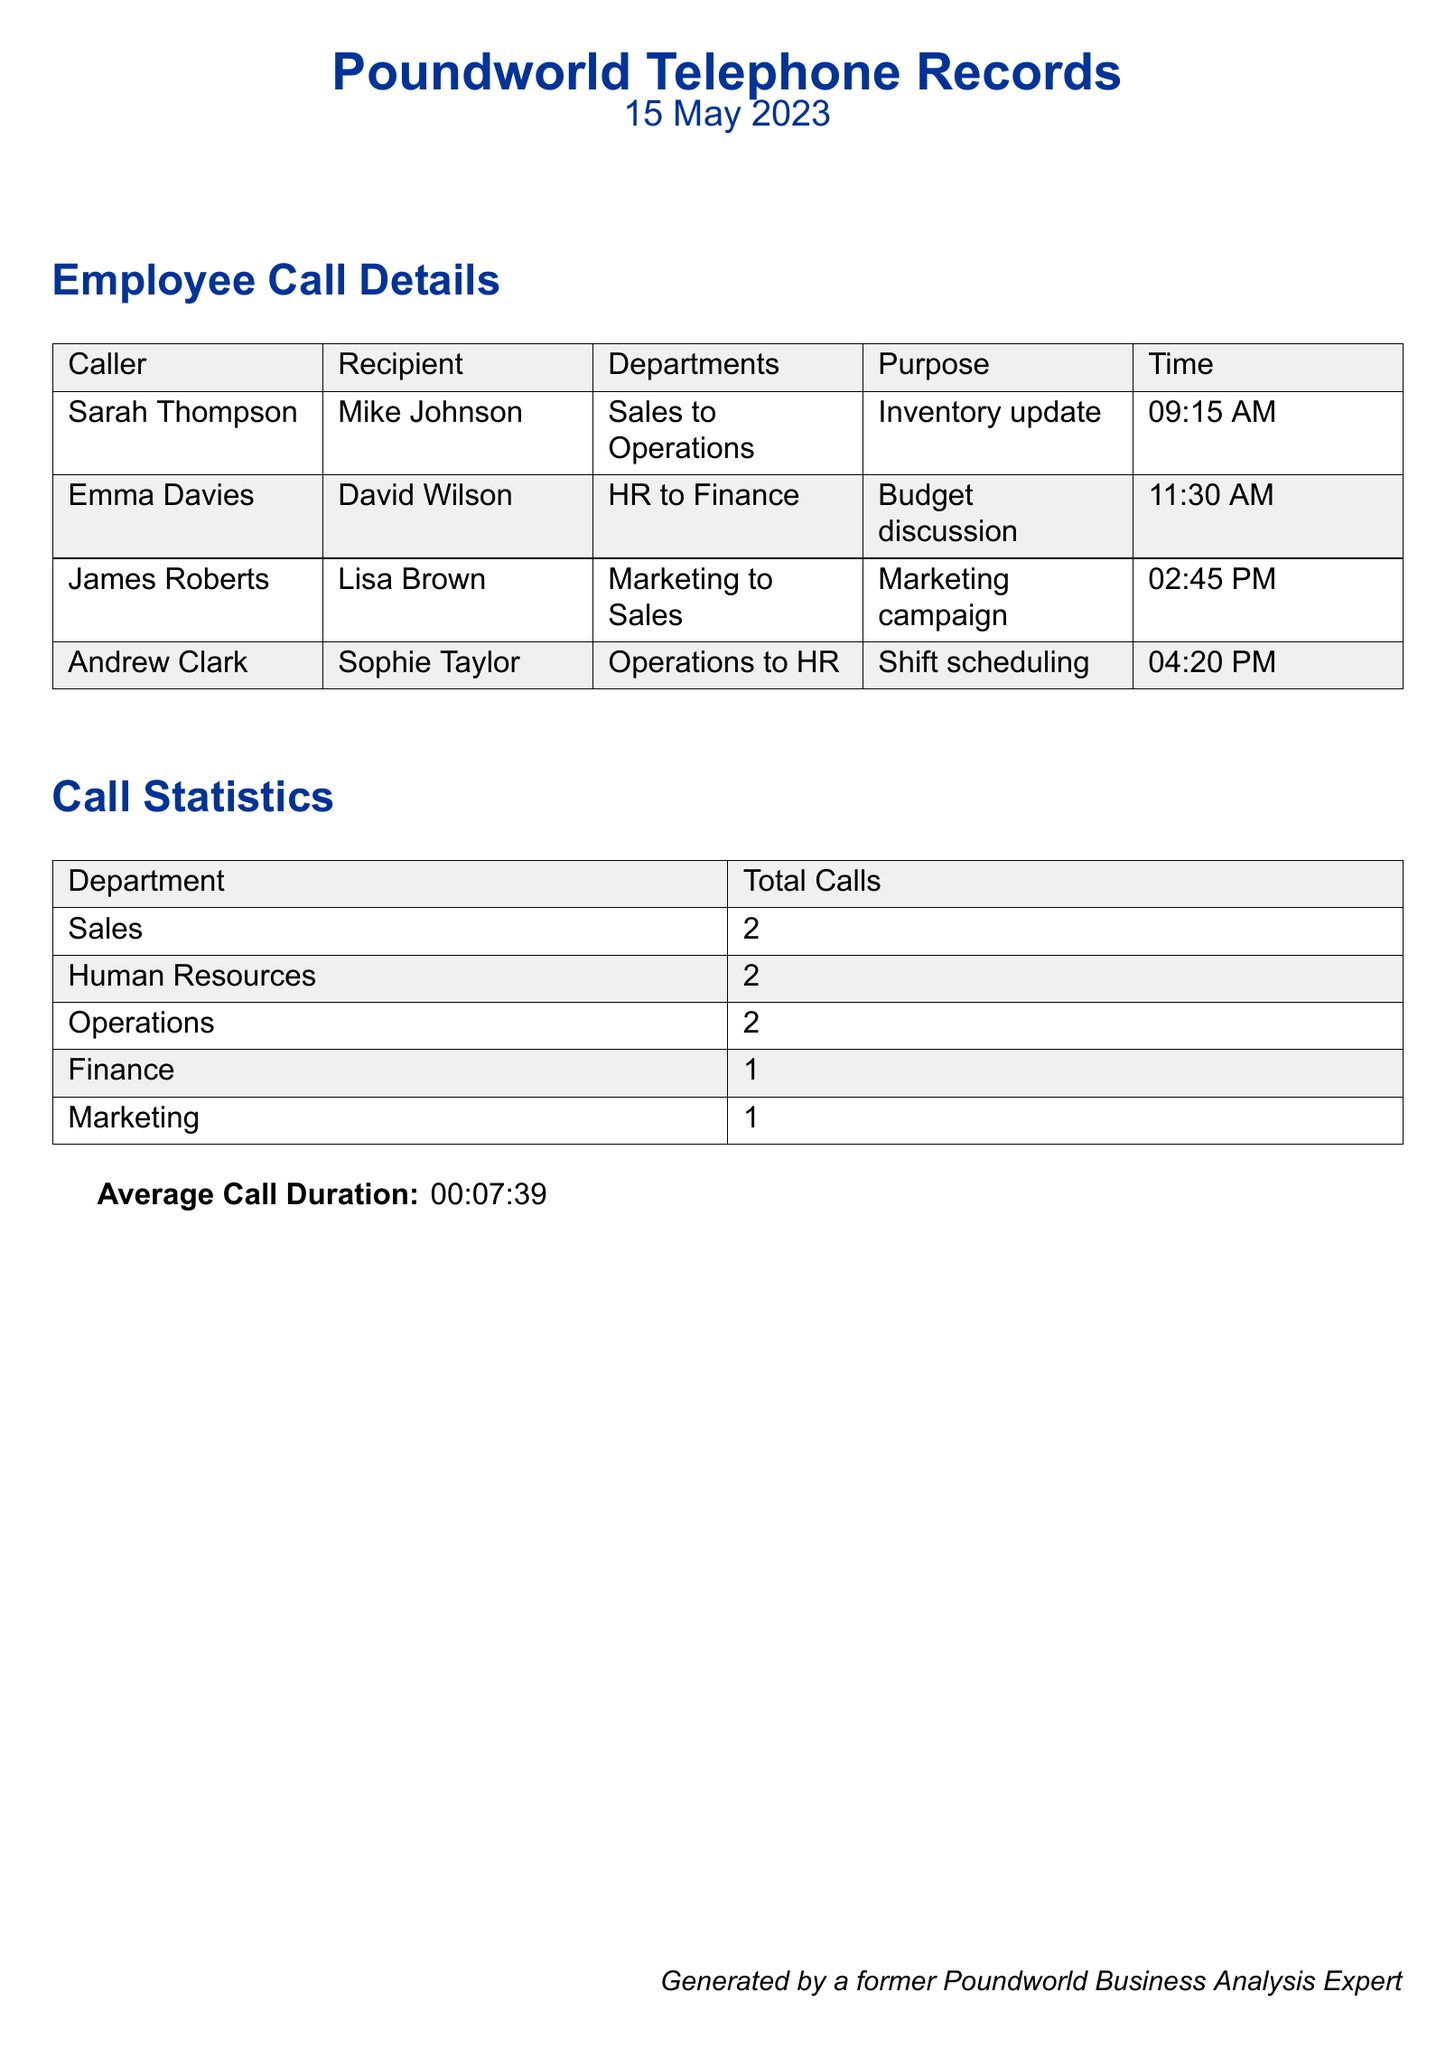What is the date of the telephone records? The date of the telephone records is mentioned at the top of the document as "15 May 2023."
Answer: 15 May 2023 Who called Mike Johnson? The caller who contacted Mike Johnson is identified as Sarah Thompson in the call details.
Answer: Sarah Thompson How many total calls were made by the Sales department? The total number of calls made by the Sales department is listed in the call statistics section as 2.
Answer: 2 What was the purpose of the call between Emma Davies and David Wilson? The purpose of the call is stated in the document as a "Budget discussion."
Answer: Budget discussion Which department made the fewest calls? By analyzing the call statistics, the department with the fewest calls is Finance, with only 1 call.
Answer: Finance What is the average call duration mentioned in the document? The average call duration is specified near the end of the document as 00:07:39.
Answer: 00:07:39 Who is the recipient of the call for the shift scheduling purpose? Sophie Taylor is identified as the recipient of the call regarding shift scheduling.
Answer: Sophie Taylor Which department is involved in the marketing campaign call? The department involved in the marketing campaign call is Marketing, as indicated in the call details.
Answer: Marketing What time did Andrew Clark call Sophie Taylor? The time mentioned for Andrew Clark's call to Sophie Taylor is 04:20 PM.
Answer: 04:20 PM 